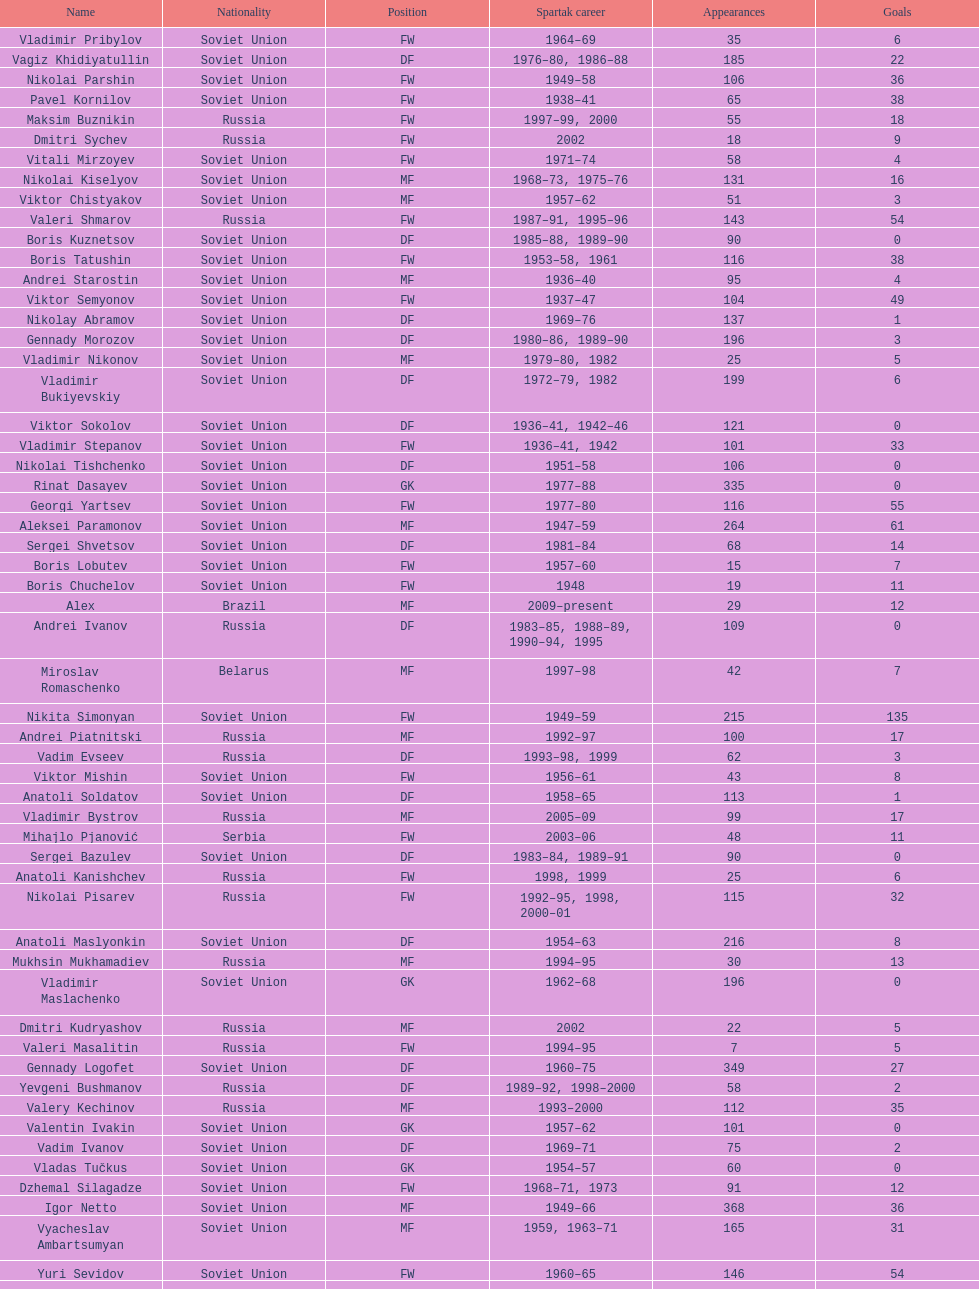Parse the full table. {'header': ['Name', 'Nationality', 'Position', 'Spartak career', 'Appearances', 'Goals'], 'rows': [['Vladimir Pribylov', 'Soviet Union', 'FW', '1964–69', '35', '6'], ['Vagiz Khidiyatullin', 'Soviet Union', 'DF', '1976–80, 1986–88', '185', '22'], ['Nikolai Parshin', 'Soviet Union', 'FW', '1949–58', '106', '36'], ['Pavel Kornilov', 'Soviet Union', 'FW', '1938–41', '65', '38'], ['Maksim Buznikin', 'Russia', 'FW', '1997–99, 2000', '55', '18'], ['Dmitri Sychev', 'Russia', 'FW', '2002', '18', '9'], ['Vitali Mirzoyev', 'Soviet Union', 'FW', '1971–74', '58', '4'], ['Nikolai Kiselyov', 'Soviet Union', 'MF', '1968–73, 1975–76', '131', '16'], ['Viktor Chistyakov', 'Soviet Union', 'MF', '1957–62', '51', '3'], ['Valeri Shmarov', 'Russia', 'FW', '1987–91, 1995–96', '143', '54'], ['Boris Kuznetsov', 'Soviet Union', 'DF', '1985–88, 1989–90', '90', '0'], ['Boris Tatushin', 'Soviet Union', 'FW', '1953–58, 1961', '116', '38'], ['Andrei Starostin', 'Soviet Union', 'MF', '1936–40', '95', '4'], ['Viktor Semyonov', 'Soviet Union', 'FW', '1937–47', '104', '49'], ['Nikolay Abramov', 'Soviet Union', 'DF', '1969–76', '137', '1'], ['Gennady Morozov', 'Soviet Union', 'DF', '1980–86, 1989–90', '196', '3'], ['Vladimir Nikonov', 'Soviet Union', 'MF', '1979–80, 1982', '25', '5'], ['Vladimir Bukiyevskiy', 'Soviet Union', 'DF', '1972–79, 1982', '199', '6'], ['Viktor Sokolov', 'Soviet Union', 'DF', '1936–41, 1942–46', '121', '0'], ['Vladimir Stepanov', 'Soviet Union', 'FW', '1936–41, 1942', '101', '33'], ['Nikolai Tishchenko', 'Soviet Union', 'DF', '1951–58', '106', '0'], ['Rinat Dasayev', 'Soviet Union', 'GK', '1977–88', '335', '0'], ['Georgi Yartsev', 'Soviet Union', 'FW', '1977–80', '116', '55'], ['Aleksei Paramonov', 'Soviet Union', 'MF', '1947–59', '264', '61'], ['Sergei Shvetsov', 'Soviet Union', 'DF', '1981–84', '68', '14'], ['Boris Lobutev', 'Soviet Union', 'FW', '1957–60', '15', '7'], ['Boris Chuchelov', 'Soviet Union', 'FW', '1948', '19', '11'], ['Alex', 'Brazil', 'MF', '2009–present', '29', '12'], ['Andrei Ivanov', 'Russia', 'DF', '1983–85, 1988–89, 1990–94, 1995', '109', '0'], ['Miroslav Romaschenko', 'Belarus', 'MF', '1997–98', '42', '7'], ['Nikita Simonyan', 'Soviet Union', 'FW', '1949–59', '215', '135'], ['Andrei Piatnitski', 'Russia', 'MF', '1992–97', '100', '17'], ['Vadim Evseev', 'Russia', 'DF', '1993–98, 1999', '62', '3'], ['Viktor Mishin', 'Soviet Union', 'FW', '1956–61', '43', '8'], ['Anatoli Soldatov', 'Soviet Union', 'DF', '1958–65', '113', '1'], ['Vladimir Bystrov', 'Russia', 'MF', '2005–09', '99', '17'], ['Mihajlo Pjanović', 'Serbia', 'FW', '2003–06', '48', '11'], ['Sergei Bazulev', 'Soviet Union', 'DF', '1983–84, 1989–91', '90', '0'], ['Anatoli Kanishchev', 'Russia', 'FW', '1998, 1999', '25', '6'], ['Nikolai Pisarev', 'Russia', 'FW', '1992–95, 1998, 2000–01', '115', '32'], ['Anatoli Maslyonkin', 'Soviet Union', 'DF', '1954–63', '216', '8'], ['Mukhsin Mukhamadiev', 'Russia', 'MF', '1994–95', '30', '13'], ['Vladimir Maslachenko', 'Soviet Union', 'GK', '1962–68', '196', '0'], ['Dmitri Kudryashov', 'Russia', 'MF', '2002', '22', '5'], ['Valeri Masalitin', 'Russia', 'FW', '1994–95', '7', '5'], ['Gennady Logofet', 'Soviet Union', 'DF', '1960–75', '349', '27'], ['Yevgeni Bushmanov', 'Russia', 'DF', '1989–92, 1998–2000', '58', '2'], ['Valery Kechinov', 'Russia', 'MF', '1993–2000', '112', '35'], ['Valentin Ivakin', 'Soviet Union', 'GK', '1957–62', '101', '0'], ['Vadim Ivanov', 'Soviet Union', 'DF', '1969–71', '75', '2'], ['Vladas Tučkus', 'Soviet Union', 'GK', '1954–57', '60', '0'], ['Dzhemal Silagadze', 'Soviet Union', 'FW', '1968–71, 1973', '91', '12'], ['Igor Netto', 'Soviet Union', 'MF', '1949–66', '368', '36'], ['Vyacheslav Ambartsumyan', 'Soviet Union', 'MF', '1959, 1963–71', '165', '31'], ['Yuri Sevidov', 'Soviet Union', 'FW', '1960–65', '146', '54'], ['Sergei Yuran', 'Russia', 'FW', '1995, 1999', '26', '5'], ['Mozart', 'Brazil', 'MF', '2005–08', '68', '7'], ['Malik Fathi', 'Germany', 'DF', '2008–09', '37', '6'], ['Valeri Reyngold', 'Soviet Union', 'FW', '1960–67', '176', '32'], ['Georgi Glazkov', 'Soviet Union', 'FW', '1936–41, 1946–47', '106', '48'], ['Ivan Mozer', 'Soviet Union', 'MF', '1956–61', '96', '30'], ['Vadim Pavlenko', 'Soviet Union', 'FW', '1977–78', '47', '16'], ['Mikhail Bulgakov', 'Soviet Union', 'MF', '1970–79', '205', '39'], ['Aleksei Sokolov', 'Soviet Union', 'FW', '1938–41, 1942, 1944–47', '114', '49'], ['Yuri Kovtun', 'Russia', 'DF', '1999–2005', '122', '7'], ['Vladimir Petrov', 'Soviet Union', 'DF', '1959–71', '174', '5'], ['Anatoli Ilyin', 'Soviet Union', 'FW', '1949–62', '228', '84'], ['Anatoli Seglin', 'Soviet Union', 'DF', '1945–52', '83', '0'], ['Valeri Dikaryov', 'Soviet Union', 'DF', '1961–67', '192', '1'], ['Andrei Rudakov', 'Soviet Union', 'FW', '1985–87', '49', '17'], ['Aleksandr Kokorev', 'Soviet Union', 'MF', '1972–80', '90', '4'], ['Artyom Bezrodny', 'Russia', 'MF', '1995–97, 1998–2003', '55', '10'], ['Andrejs Štolcers', 'Latvia', 'MF', '2000', '11', '5'], ['Sergey Rodionov', 'Russia', 'FW', '1979–90, 1993–95', '303', '124'], ['Andrei Protasov', 'Soviet Union', 'FW', '1939–41', '32', '10'], ['Konstantin Malinin', 'Soviet Union', 'DF', '1939–50', '140', '7'], ['Aleksandr Bubnov', 'Soviet Union', 'DF', '1983–89', '169', '3'], ['Sergei Rozhkov', 'Soviet Union', 'MF', '1961–65, 1967–69, 1974', '143', '8'], ['Valeri Gladilin', 'Soviet Union', 'MF', '1974–78, 1983–84', '169', '28'], ['Dmitri Popov', 'Russia', 'DF', '1989–93', '78', '7'], ['Evgeny Lovchev', 'Soviet Union', 'MF', '1969–78', '249', '30'], ['Viktor Konovalov', 'Soviet Union', 'MF', '1960–61', '24', '5'], ['Viktor Samokhin', 'Soviet Union', 'MF', '1974–81', '188', '3'], ['Dmitri Radchenko', 'Russia', 'FW', '1991–93', '61', '27'], ['Grigori Tuchkov', 'Soviet Union', 'DF', '1937–41, 1942, 1944', '74', '2'], ['Yegor Titov', 'Russia', 'MF', '1992–2008', '324', '86'], ['Aleksandr Pavlenko', 'Russia', 'MF', '2001–07, 2008–09', '110', '11'], ['Sergei Artemyev', 'Soviet Union', 'MF', '1936–40', '53', '0'], ['Yuri Sedov', 'Soviet Union', 'DF', '1948–55, 1957–59', '176', '2'], ['Viktor Papayev', 'Soviet Union', 'MF', '1968–73, 1975–76', '174', '10'], ['Aleksandr Mostovoi', 'Soviet Union', 'MF', '1986–91', '106', '34'], ['Oleg Romantsev', 'Soviet Union', 'DF', '1976–83', '180', '6'], ['Igor Shalimov', 'Russia', 'MF', '1986–91', '95', '20'], ['Aleksandr Grebnev', 'Soviet Union', 'DF', '1966–69', '54', '1'], ['Sergey Shavlo', 'Soviet Union', 'MF', '1977–82, 1984–85', '256', '48'], ['Vladimir Redin', 'Soviet Union', 'MF', '1970–74, 1976', '90', '12'], ['Aleksandr Prokhorov', 'Soviet Union', 'GK', '1972–75, 1976–78', '143', '0'], ['Yevgeni Kuznetsov', 'Soviet Union', 'MF', '1982–89', '209', '23'], ['Anatoli Isayev', 'Soviet Union', 'FW', '1953–62', '159', '53'], ['Vladimir Kapustin', 'Soviet Union', 'MF', '1985–89', '51', '1'], ['Roman Pavlyuchenko', 'Russia', 'FW', '2003–08', '141', '69'], ['Yuri Syomin', 'Soviet Union', 'MF', '1965–67', '43', '6'], ['Nikolay Dementyev', 'Soviet Union', 'FW', '1946–54', '186', '55'], ['Vasili Kulkov', 'Russia', 'DF', '1986, 1989–91, 1995, 1997', '93', '4'], ['Vladimir Yankin', 'Soviet Union', 'MF', '1966–70', '93', '19'], ['Anatoli Akimov', 'Soviet Union', 'GK', '1936–37, 1939–41', '60', '0'], ['Stanislav Cherchesov', 'Russia', 'GK', '1984–87, 1989–93, 1995, 2002', '149', '0'], ['Aleksandr Sorokin', 'Soviet Union', 'MF', '1977–80', '107', '9'], ['Ivan Konov', 'Soviet Union', 'FW', '1945–48', '85', '31'], ['Sergei Novikov', 'Soviet Union', 'MF', '1978–80, 1985–89', '70', '12'], ['Alexander Mirzoyan', 'Soviet Union', 'DF', '1979–83', '80', '9'], ['Sergei Gorlukovich', 'Russia', 'DF', '1996–98', '83', '5'], ['Valery Karpin', 'Russia', 'MF', '1990–94', '117', '28'], ['Martin Jiránek', 'Czech Republic', 'DF', '2004–present', '126', '3'], ['Valentin Yemyshev', 'Soviet Union', 'FW', '1948–53', '23', '9'], ['Mikhail Rusyayev', 'Russia', 'FW', '1981–87, 1992', '47', '9'], ['Igor Mitreski', 'Macedonia', 'DF', '2001–04', '85', '0'], ['Radoslav Kováč', 'Czech Republic', 'MF', '2005–08', '101', '9'], ['Hennadiy Perepadenko', 'Ukraine', 'MF', '1990–91, 1992', '51', '6'], ['Nikolai Osyanin', 'Soviet Union', 'DF', '1966–71, 1974–76', '248', '50'], ['Aleksandr Samedov', 'Russia', 'MF', '2001–05', '47', '6'], ['Ivan Varlamov', 'Soviet Union', 'DF', '1964–68', '75', '0'], ['Luis Robson', 'Brazil', 'FW', '1997–2001', '102', '32'], ['Viktor Bulatov', 'Russia', 'MF', '1999–2001', '87', '7'], ['Sergei Salnikov', 'Soviet Union', 'FW', '1946–49, 1955–60', '201', '64'], ['Igor Lediakhov', 'Russia', 'MF', '1992–94', '65', '21'], ['Galimzyan Khusainov', 'Soviet Union', 'FW', '1961–73', '346', '102'], ['Yuri Falin', 'Soviet Union', 'MF', '1961–65, 1967', '133', '34'], ['Oleg Timakov', 'Soviet Union', 'MF', '1945–54', '182', '19'], ['Boris Smyslov', 'Soviet Union', 'FW', '1945–48', '45', '6'], ['Ilya Tsymbalar', 'Russia', 'MF', '1993–99', '146', '42'], ['Yuri Gavrilov', 'Soviet Union', 'MF', '1977–85', '280', '89'], ['Fyodor Cherenkov', 'Russia', 'MF', '1977–90, 1991, 1993', '398', '95'], ['Vladimir Beschastnykh', 'Russia', 'FW', '1991–94, 2001–02', '104', '56'], ['Aleksandr Piskaryov', 'Soviet Union', 'FW', '1971–75', '117', '33'], ['Clemente Rodríguez', 'Argentina', 'DF', '2004–06, 2008–09', '71', '3'], ['Aleksei Melyoshin', 'Russia', 'MF', '1995–2000', '68', '5'], ['Anzor Kavazashvili', 'Soviet Union', 'GK', '1969–71', '74', '0'], ['Vasili Sokolov', 'Soviet Union', 'DF', '1938–41, 1942–51', '262', '2'], ['Serghei Covalciuc', 'Moldova', 'MF', '2004–09', '90', '2'], ['Edgar Gess', 'Soviet Union', 'MF', '1979–83', '114', '26'], ['Dmitri Khlestov', 'Russia', 'DF', '1989–2000, 2002', '201', '6'], ['Yevgeni Sidorov', 'Soviet Union', 'MF', '1974–81, 1984–85', '191', '18'], ['Yuri Susloparov', 'Soviet Union', 'DF', '1986–90', '80', '1'], ['Ramiz Mamedov', 'Russia', 'DF', '1991–98', '125', '6'], ['Denis Boyarintsev', 'Russia', 'MF', '2005–07, 2009', '91', '9'], ['Dimitri Ananko', 'Russia', 'DF', '1990–94, 1995–2002', '150', '1'], ['Viktor Terentyev', 'Soviet Union', 'FW', '1948–53', '103', '34'], ['Valeri Zenkov', 'Soviet Union', 'DF', '1971–74', '59', '1'], ['Maksym Kalynychenko', 'Ukraine', 'MF', '2000–08', '134', '22'], ['Aleksandr Kalashnikov', 'Soviet Union', 'FW', '1978–82', '67', '16'], ['Viktor Onopko', 'Russia', 'DF', '1992–95', '108', '23'], ['Vasili Kalinov', 'Soviet Union', 'MF', '1969–72', '83', '10'], ['Serafim Kholodkov', 'Soviet Union', 'DF', '1941, 1946–49', '90', '0'], ['Viktor Pasulko', 'Soviet Union', 'MF', '1987–89', '75', '16'], ['Boris Pozdnyakov', 'Soviet Union', 'DF', '1978–84, 1989–91', '145', '3'], ['Dmitri Alenichev', 'Russia', 'MF', '1994–98, 2004–06', '143', '21'], ['Aleksandr Filimonov', 'Russia', 'GK', '1996–2001', '147', '0'], ['Mikhail Ogonkov', 'Soviet Union', 'DF', '1953–58, 1961', '78', '0'], ['Boris Petrov', 'Soviet Union', 'FW', '1962', '18', '5'], ['Roman Shishkin', 'Russia', 'DF', '2003–08', '54', '1'], ['Alexey Korneyev', 'Soviet Union', 'DF', '1957–67', '177', '0'], ['Yuriy Nikiforov', 'Russia', 'DF', '1993–96', '85', '16'], ['Wojciech Kowalewski', 'Poland', 'GK', '2003–07', '94', '0'], ['Vladimir Sochnov', 'Soviet Union', 'DF', '1981–85, 1989', '148', '9'], ['Aleksei Leontyev', 'Soviet Union', 'GK', '1940–49', '109', '0'], ['Sergei Olshansky', 'Soviet Union', 'DF', '1969–75', '138', '7'], ['Florin Şoavă', 'Romania', 'DF', '2004–05, 2007–08', '52', '1'], ['Fernando Cavenaghi', 'Argentina', 'FW', '2004–06', '51', '12'], ['Eduard Tsykhmeystruk', 'Ukraine', 'FW', '2001–02', '35', '5'], ['Vasili Baranov', 'Belarus', 'MF', '1998–2003', '120', '18'], ['Aleksei Yeryomenko', 'Soviet Union', 'MF', '1986–87', '26', '5'], ['Welliton', 'Brazil', 'FW', '2007–present', '77', '51'], ['Dmytro Parfenov', 'Ukraine', 'DF', '1998–2005', '125', '15'], ['Konstantin Ryazantsev', 'Soviet Union', 'MF', '1941, 1944–51', '114', '5'], ['Vladimir Chernyshev', 'Soviet Union', 'GK', '1946–55', '74', '0'], ['Stipe Pletikosa', 'Croatia', 'GK', '2007–present', '63', '0'], ['Aleksandr Rystsov', 'Soviet Union', 'FW', '1947–54', '100', '16'], ['Valeri Andreyev', 'Soviet Union', 'FW', '1970–76, 1977', '97', '21'], ['Nikolai Gulyayev', 'Soviet Union', 'MF', '1937–46', '76', '7'], ['Aleksandr Shirko', 'Russia', 'FW', '1993–2001', '128', '40'], ['Aleksandr Minayev', 'Soviet Union', 'MF', '1972–75', '92', '10'], ['Andrey Tikhonov', 'Russia', 'MF', '1992–2000', '191', '68'], ['Viktor Yevlentyev', 'Soviet Union', 'MF', '1963–65, 1967–70', '56', '11'], ['Martin Stranzl', 'Austria', 'DF', '2006–present', '80', '3'], ['Vladimir Yanishevskiy', 'Soviet Union', 'FW', '1965–66', '46', '7'], ['Leonid Rumyantsev', 'Soviet Union', 'FW', '1936–40', '26', '8'], ['Anatoly Krutikov', 'Soviet Union', 'DF', '1959–69', '269', '9'], ['Nikita Bazhenov', 'Russia', 'FW', '2004–present', '92', '17']]} Which player has the most appearances with the club? Fyodor Cherenkov. 